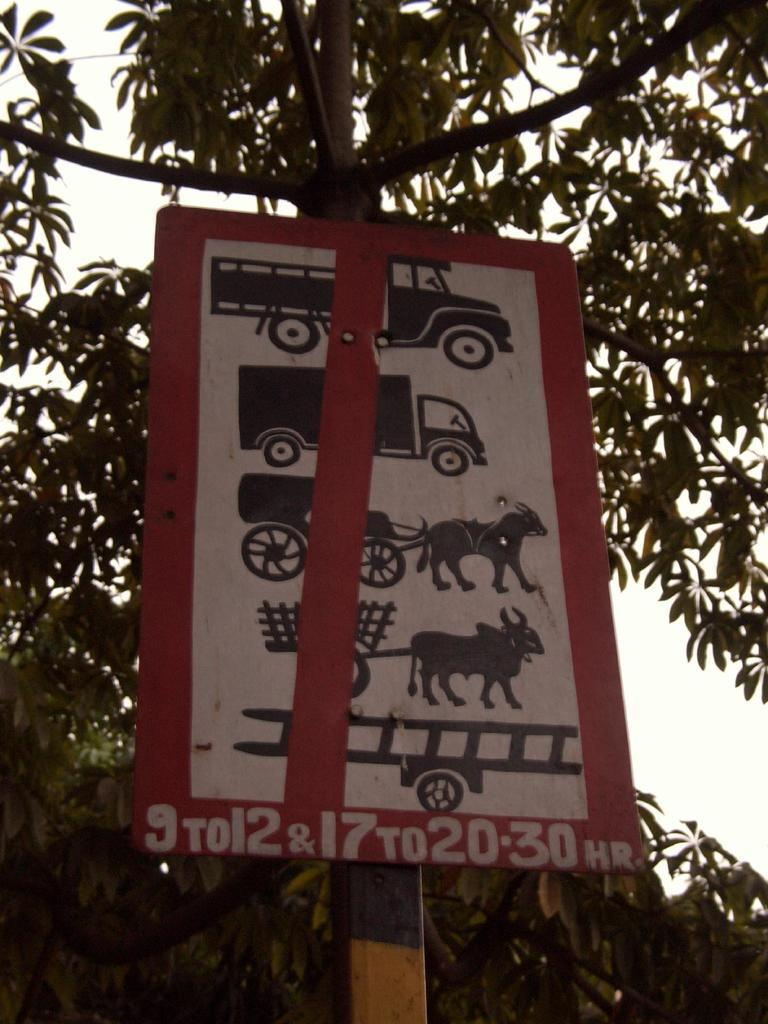What is the main object in the image? There is a board in the image. What is shown on the board? There is a tree depicted on the board. What can be seen in the background of the image? The sky is visible in the background of the image. What type of needle is used to sew the cloth on the board? There is no needle or cloth present on the board in the image; it only features a tree. 